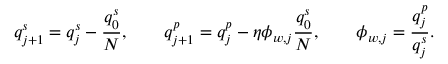<formula> <loc_0><loc_0><loc_500><loc_500>q _ { j + 1 } ^ { s } = q _ { j } ^ { s } - \frac { q _ { 0 } ^ { s } } { N } , \quad q _ { j + 1 } ^ { p } = q _ { j } ^ { p } - \eta \phi _ { w , j } \frac { q _ { 0 } ^ { s } } { N } , \quad \phi _ { w , j } = \frac { q _ { j } ^ { p } } { q _ { j } ^ { s } } .</formula> 